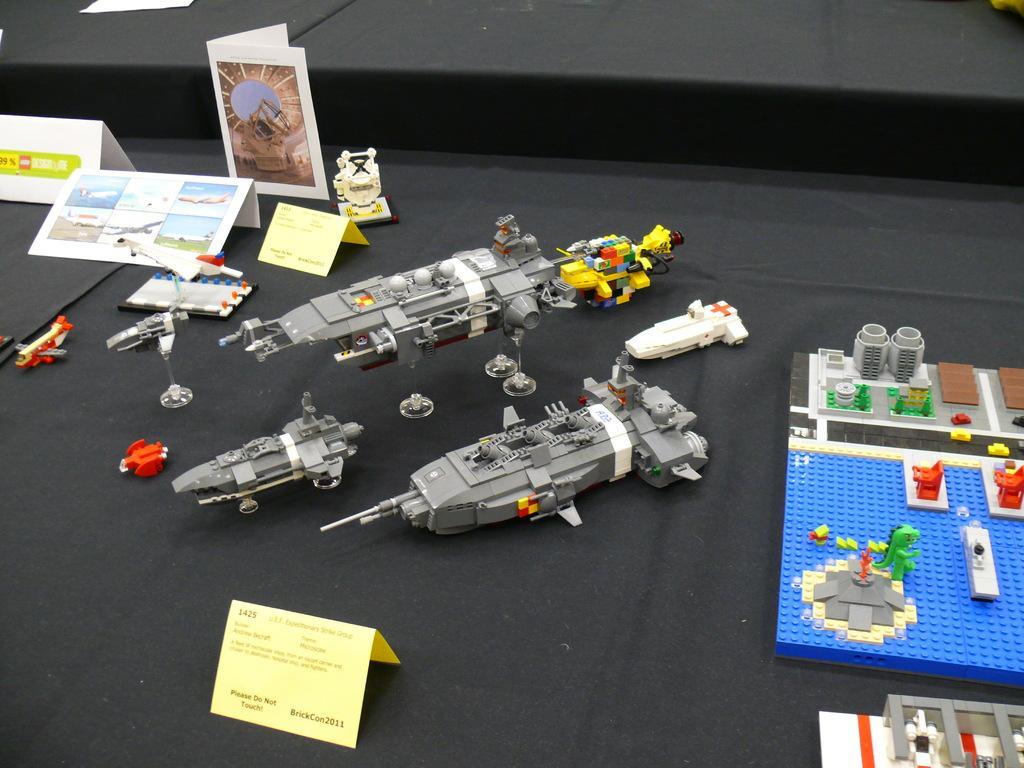In one or two sentences, can you explain what this image depicts? In this image we can see toys and paper cuttings on the black color surface. 